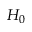Convert formula to latex. <formula><loc_0><loc_0><loc_500><loc_500>H _ { 0 }</formula> 